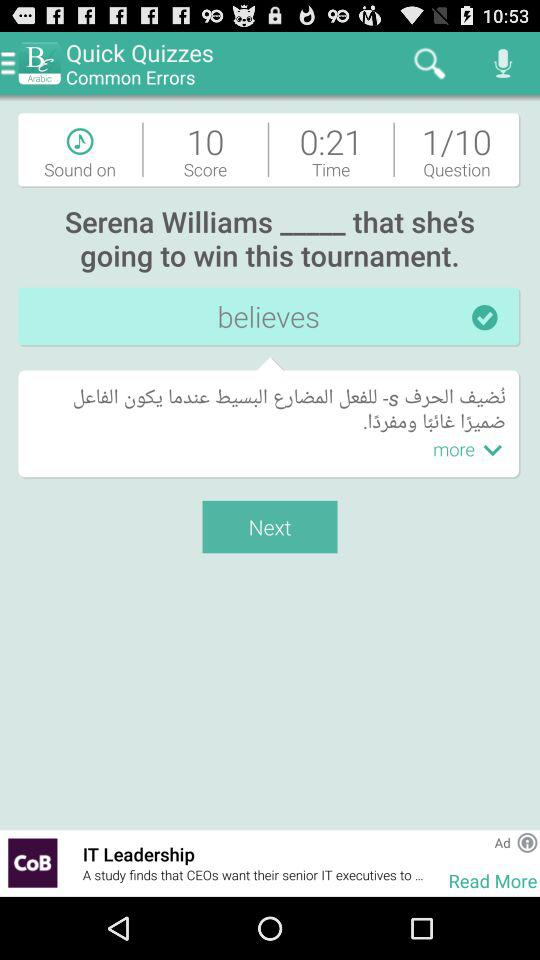What was the quiz score? The quiz score was 10. 